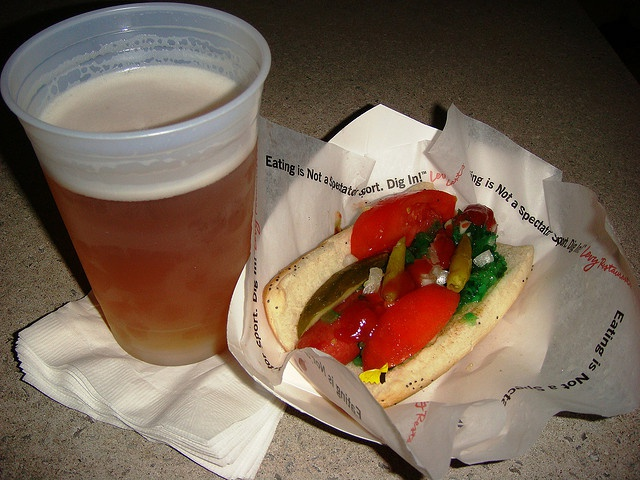Describe the objects in this image and their specific colors. I can see dining table in black and gray tones, cup in black, maroon, darkgray, and gray tones, and hot dog in black, maroon, and tan tones in this image. 